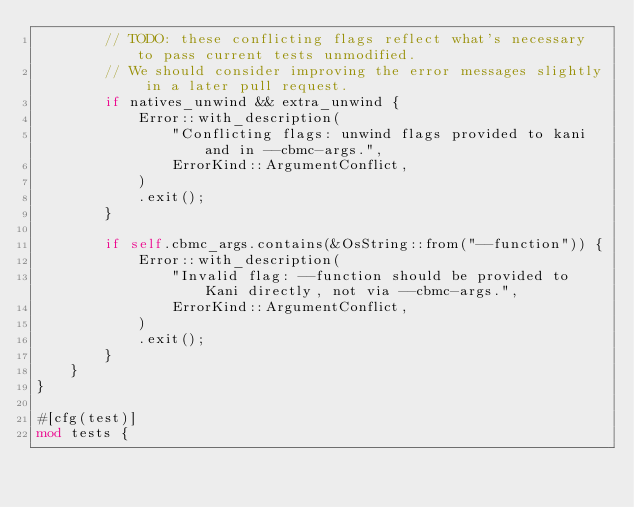<code> <loc_0><loc_0><loc_500><loc_500><_Rust_>        // TODO: these conflicting flags reflect what's necessary to pass current tests unmodified.
        // We should consider improving the error messages slightly in a later pull request.
        if natives_unwind && extra_unwind {
            Error::with_description(
                "Conflicting flags: unwind flags provided to kani and in --cbmc-args.",
                ErrorKind::ArgumentConflict,
            )
            .exit();
        }

        if self.cbmc_args.contains(&OsString::from("--function")) {
            Error::with_description(
                "Invalid flag: --function should be provided to Kani directly, not via --cbmc-args.",
                ErrorKind::ArgumentConflict,
            )
            .exit();
        }
    }
}

#[cfg(test)]
mod tests {</code> 